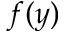<formula> <loc_0><loc_0><loc_500><loc_500>f ( y )</formula> 